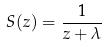<formula> <loc_0><loc_0><loc_500><loc_500>S ( z ) = \frac { 1 } { z + \lambda }</formula> 